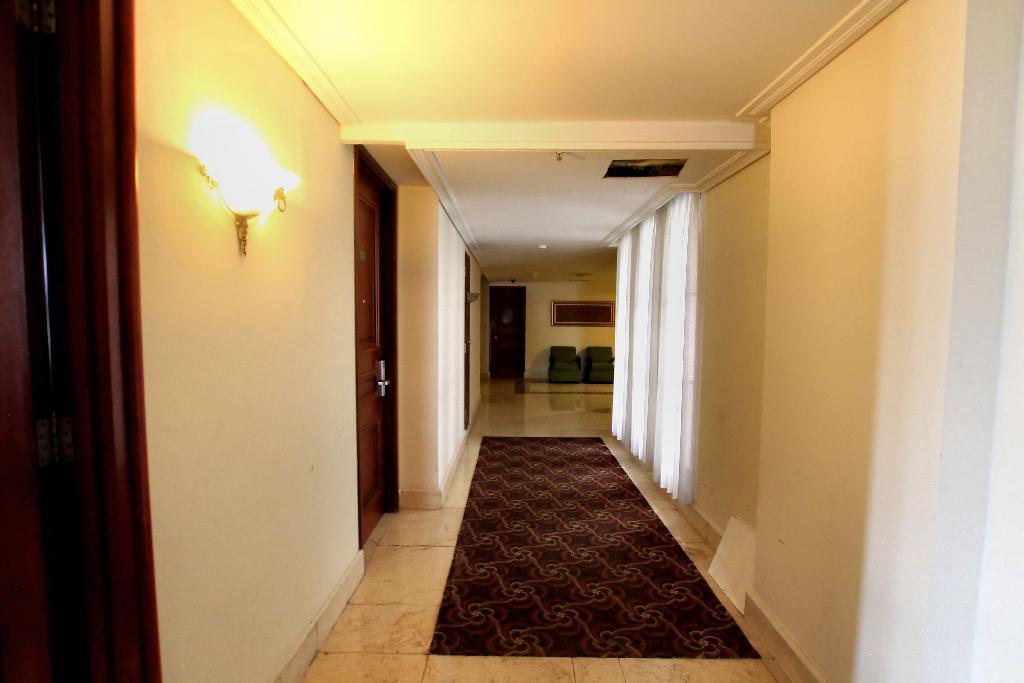Can you describe this image briefly? In the picture we can see a floor with a floor mat and besides to the wall we can see some doors and light and some curtains and in the background, we can see a door and some chairs and a photo frame to the wall. 